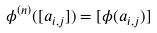Convert formula to latex. <formula><loc_0><loc_0><loc_500><loc_500>\phi ^ { ( n ) } ( [ a _ { i , j } ] ) = [ \phi ( a _ { i , j } ) ]</formula> 